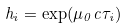<formula> <loc_0><loc_0><loc_500><loc_500>h _ { i } = \exp ( \mu _ { 0 } c \tau _ { i } )</formula> 